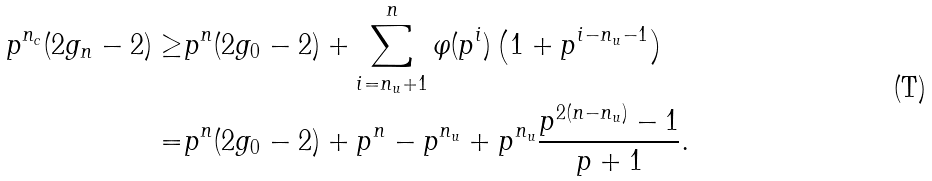Convert formula to latex. <formula><loc_0><loc_0><loc_500><loc_500>p ^ { n _ { c } } ( 2 g _ { n } - 2 ) \geq & p ^ { n } ( 2 g _ { 0 } - 2 ) + \sum _ { i = n _ { u } + 1 } ^ { n } \varphi ( p ^ { i } ) \left ( 1 + p ^ { i - n _ { u } - 1 } \right ) \\ = & p ^ { n } ( 2 g _ { 0 } - 2 ) + p ^ { n } - p ^ { n _ { u } } + p ^ { n _ { u } } \frac { p ^ { 2 ( n - n _ { u } ) } - 1 } { p + 1 } .</formula> 